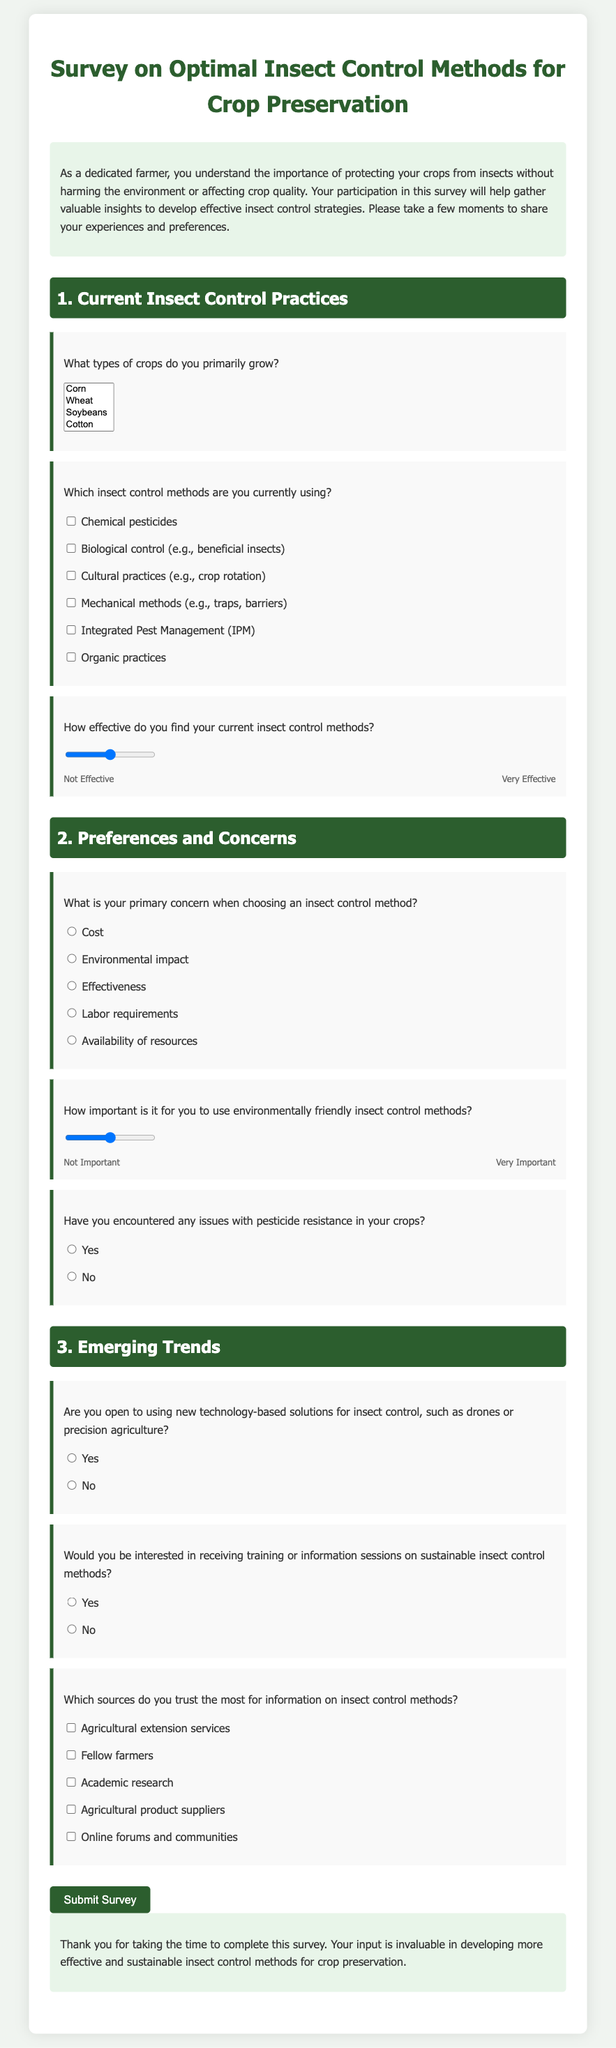What is the title of the survey? The title of the survey as seen in the document is "Survey on Optimal Insect Control Methods for Crop Preservation."
Answer: Survey on Optimal Insect Control Methods for Crop Preservation How many sections are in the survey? The document contains three distinct sections covering different topics related to insect control methods.
Answer: 3 What is the maximum rating on the effectiveness scale? The scale provided in the document for rating effectiveness ranges from 1 to 5, with 5 being the highest.
Answer: 5 What type of crops can be selected in the survey? The survey allows selection of multiple crop types, such as Corn, Wheat, Soybeans, Cotton, Vegetables, Fruits, and Others.
Answer: Corn, Wheat, Soybeans, Cotton, Vegetables, Fruits, Others What is the main concern when choosing insect control methods? The survey lists various concerns including Cost, Environmental impact, Effectiveness, Labor requirements, and Availability of resources.
Answer: Cost Are respondents allowed to select more than one insect control method currently used? The survey format for the insect control methods section utilizes checkboxes, which allows participants to choose multiple methods.
Answer: Yes What technology-based solutions are mentioned in the survey? The document references new technology-based solutions such as drones and precision agriculture for insect control.
Answer: Drones, precision agriculture What response option is provided for pesticide resistance? The respondents can choose a simple "Yes" or "No" option regarding their experiences with pesticide resistance.
Answer: Yes What action does the survey request at the end? The concluding part of the document encourages participants to submit their survey responses.
Answer: Submit Survey 